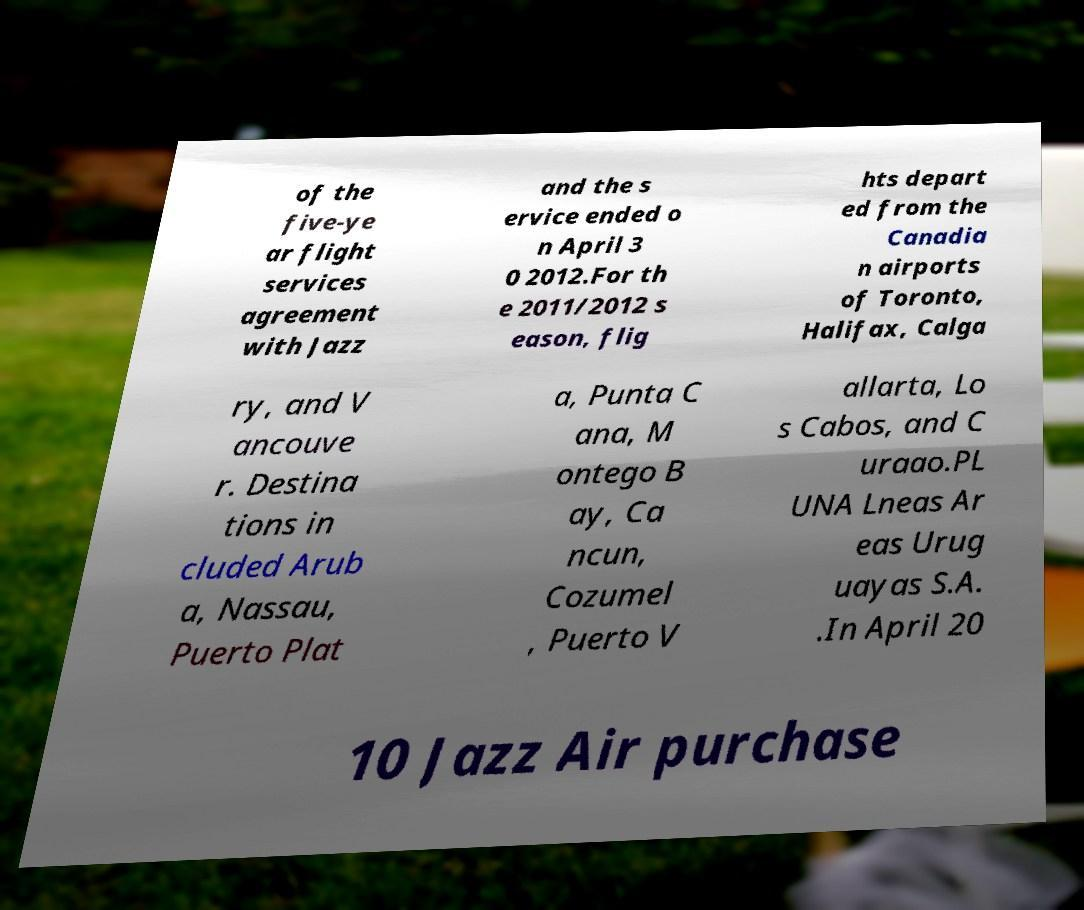There's text embedded in this image that I need extracted. Can you transcribe it verbatim? of the five-ye ar flight services agreement with Jazz and the s ervice ended o n April 3 0 2012.For th e 2011/2012 s eason, flig hts depart ed from the Canadia n airports of Toronto, Halifax, Calga ry, and V ancouve r. Destina tions in cluded Arub a, Nassau, Puerto Plat a, Punta C ana, M ontego B ay, Ca ncun, Cozumel , Puerto V allarta, Lo s Cabos, and C uraao.PL UNA Lneas Ar eas Urug uayas S.A. .In April 20 10 Jazz Air purchase 